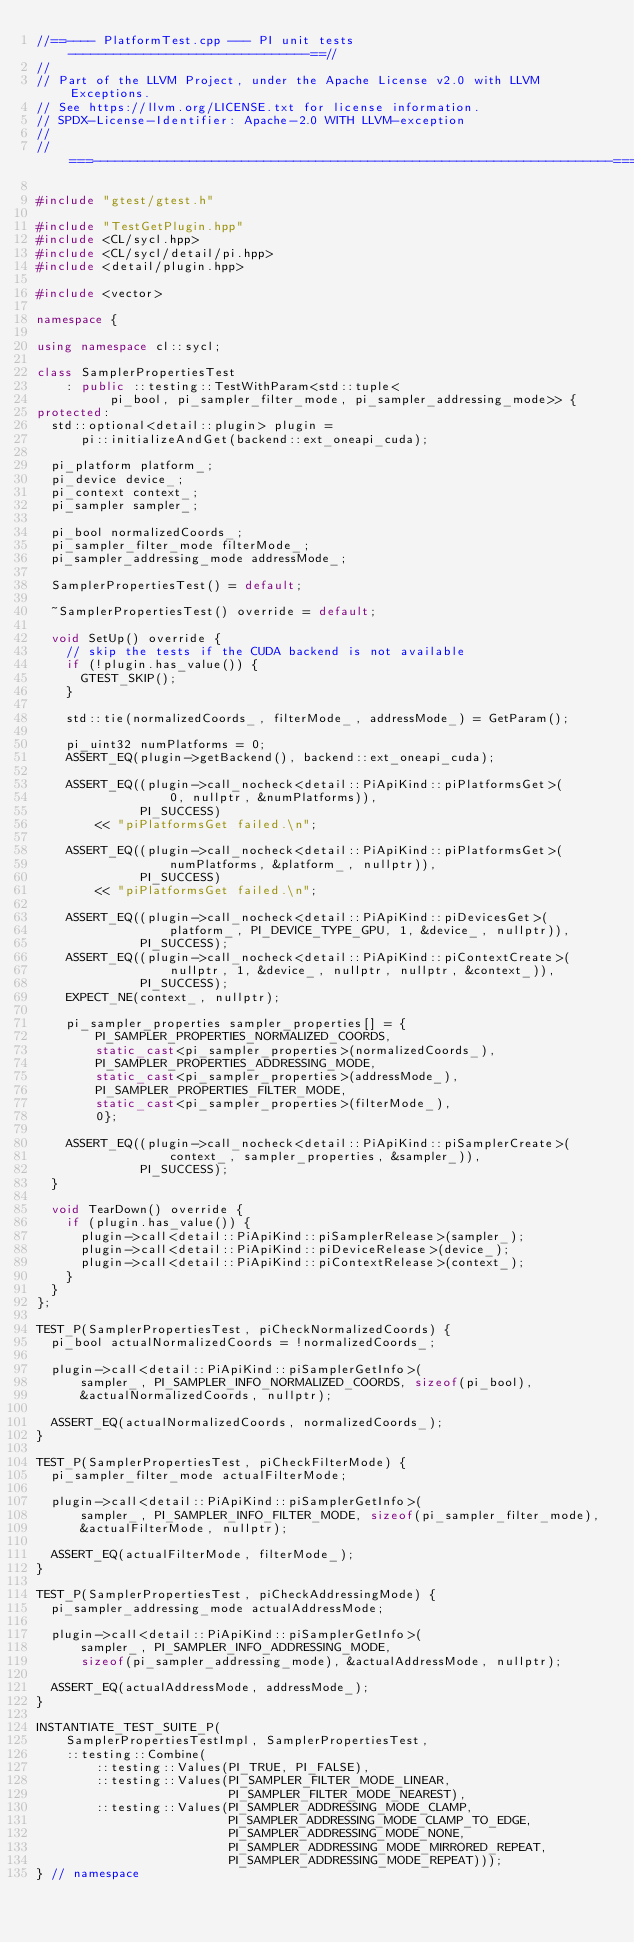Convert code to text. <code><loc_0><loc_0><loc_500><loc_500><_C++_>//==---- PlatformTest.cpp --- PI unit tests --------------------------------==//
//
// Part of the LLVM Project, under the Apache License v2.0 with LLVM Exceptions.
// See https://llvm.org/LICENSE.txt for license information.
// SPDX-License-Identifier: Apache-2.0 WITH LLVM-exception
//
//===----------------------------------------------------------------------===//

#include "gtest/gtest.h"

#include "TestGetPlugin.hpp"
#include <CL/sycl.hpp>
#include <CL/sycl/detail/pi.hpp>
#include <detail/plugin.hpp>

#include <vector>

namespace {

using namespace cl::sycl;

class SamplerPropertiesTest
    : public ::testing::TestWithParam<std::tuple<
          pi_bool, pi_sampler_filter_mode, pi_sampler_addressing_mode>> {
protected:
  std::optional<detail::plugin> plugin =
      pi::initializeAndGet(backend::ext_oneapi_cuda);

  pi_platform platform_;
  pi_device device_;
  pi_context context_;
  pi_sampler sampler_;

  pi_bool normalizedCoords_;
  pi_sampler_filter_mode filterMode_;
  pi_sampler_addressing_mode addressMode_;

  SamplerPropertiesTest() = default;

  ~SamplerPropertiesTest() override = default;

  void SetUp() override {
    // skip the tests if the CUDA backend is not available
    if (!plugin.has_value()) {
      GTEST_SKIP();
    }

    std::tie(normalizedCoords_, filterMode_, addressMode_) = GetParam();

    pi_uint32 numPlatforms = 0;
    ASSERT_EQ(plugin->getBackend(), backend::ext_oneapi_cuda);

    ASSERT_EQ((plugin->call_nocheck<detail::PiApiKind::piPlatformsGet>(
                  0, nullptr, &numPlatforms)),
              PI_SUCCESS)
        << "piPlatformsGet failed.\n";

    ASSERT_EQ((plugin->call_nocheck<detail::PiApiKind::piPlatformsGet>(
                  numPlatforms, &platform_, nullptr)),
              PI_SUCCESS)
        << "piPlatformsGet failed.\n";

    ASSERT_EQ((plugin->call_nocheck<detail::PiApiKind::piDevicesGet>(
                  platform_, PI_DEVICE_TYPE_GPU, 1, &device_, nullptr)),
              PI_SUCCESS);
    ASSERT_EQ((plugin->call_nocheck<detail::PiApiKind::piContextCreate>(
                  nullptr, 1, &device_, nullptr, nullptr, &context_)),
              PI_SUCCESS);
    EXPECT_NE(context_, nullptr);

    pi_sampler_properties sampler_properties[] = {
        PI_SAMPLER_PROPERTIES_NORMALIZED_COORDS,
        static_cast<pi_sampler_properties>(normalizedCoords_),
        PI_SAMPLER_PROPERTIES_ADDRESSING_MODE,
        static_cast<pi_sampler_properties>(addressMode_),
        PI_SAMPLER_PROPERTIES_FILTER_MODE,
        static_cast<pi_sampler_properties>(filterMode_),
        0};

    ASSERT_EQ((plugin->call_nocheck<detail::PiApiKind::piSamplerCreate>(
                  context_, sampler_properties, &sampler_)),
              PI_SUCCESS);
  }

  void TearDown() override {
    if (plugin.has_value()) {
      plugin->call<detail::PiApiKind::piSamplerRelease>(sampler_);
      plugin->call<detail::PiApiKind::piDeviceRelease>(device_);
      plugin->call<detail::PiApiKind::piContextRelease>(context_);
    }
  }
};

TEST_P(SamplerPropertiesTest, piCheckNormalizedCoords) {
  pi_bool actualNormalizedCoords = !normalizedCoords_;

  plugin->call<detail::PiApiKind::piSamplerGetInfo>(
      sampler_, PI_SAMPLER_INFO_NORMALIZED_COORDS, sizeof(pi_bool),
      &actualNormalizedCoords, nullptr);

  ASSERT_EQ(actualNormalizedCoords, normalizedCoords_);
}

TEST_P(SamplerPropertiesTest, piCheckFilterMode) {
  pi_sampler_filter_mode actualFilterMode;

  plugin->call<detail::PiApiKind::piSamplerGetInfo>(
      sampler_, PI_SAMPLER_INFO_FILTER_MODE, sizeof(pi_sampler_filter_mode),
      &actualFilterMode, nullptr);

  ASSERT_EQ(actualFilterMode, filterMode_);
}

TEST_P(SamplerPropertiesTest, piCheckAddressingMode) {
  pi_sampler_addressing_mode actualAddressMode;

  plugin->call<detail::PiApiKind::piSamplerGetInfo>(
      sampler_, PI_SAMPLER_INFO_ADDRESSING_MODE,
      sizeof(pi_sampler_addressing_mode), &actualAddressMode, nullptr);

  ASSERT_EQ(actualAddressMode, addressMode_);
}

INSTANTIATE_TEST_SUITE_P(
    SamplerPropertiesTestImpl, SamplerPropertiesTest,
    ::testing::Combine(
        ::testing::Values(PI_TRUE, PI_FALSE),
        ::testing::Values(PI_SAMPLER_FILTER_MODE_LINEAR,
                          PI_SAMPLER_FILTER_MODE_NEAREST),
        ::testing::Values(PI_SAMPLER_ADDRESSING_MODE_CLAMP,
                          PI_SAMPLER_ADDRESSING_MODE_CLAMP_TO_EDGE,
                          PI_SAMPLER_ADDRESSING_MODE_NONE,
                          PI_SAMPLER_ADDRESSING_MODE_MIRRORED_REPEAT,
                          PI_SAMPLER_ADDRESSING_MODE_REPEAT)));
} // namespace
</code> 